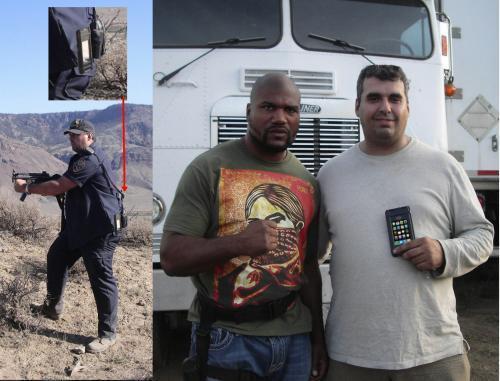How many people are there?
Give a very brief answer. 4. 